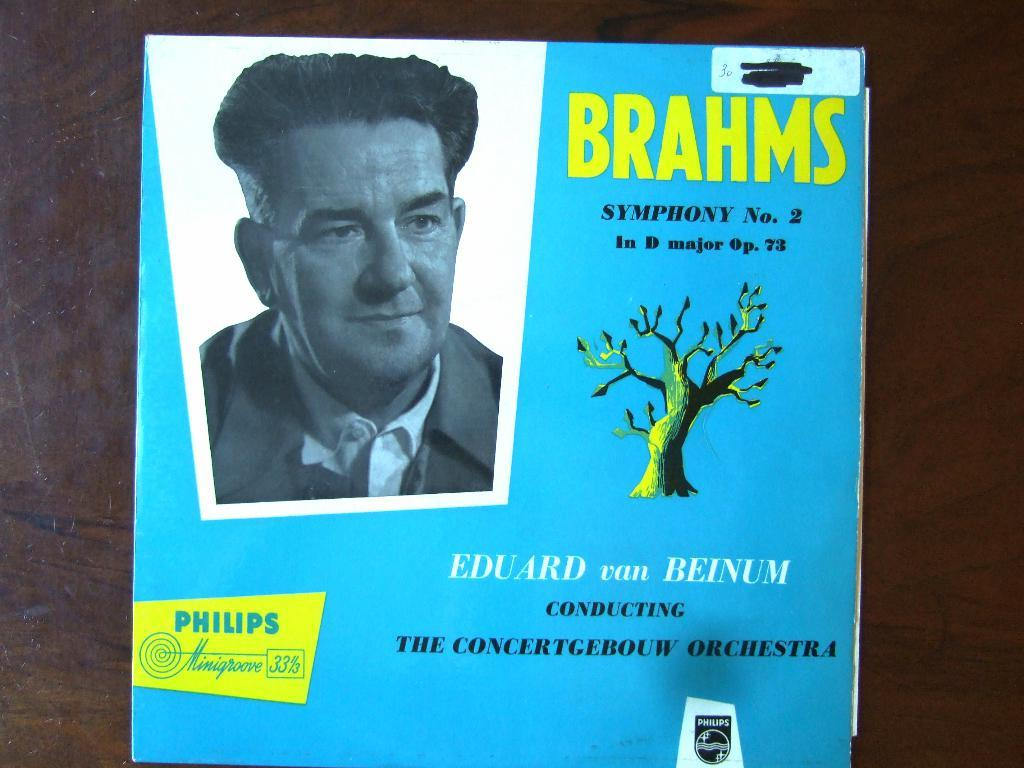What is the main subject of the image? The main subject of the image is the cover page of a book. What can be seen on the cover page? The cover page has a picture of a person and a logo. Is there any text on the cover page? Yes, there is text on the cover page. Where is the book located in the image? The book is placed on a table. What type of produce is being harvested in the image? There is no produce or harvesting activity present in the image; it features the cover page of a book. What genre of fiction is depicted on the cover page? The image does not depict any specific genre of fiction, as it only shows the cover page of a book with a picture of a person, a logo, and text. 